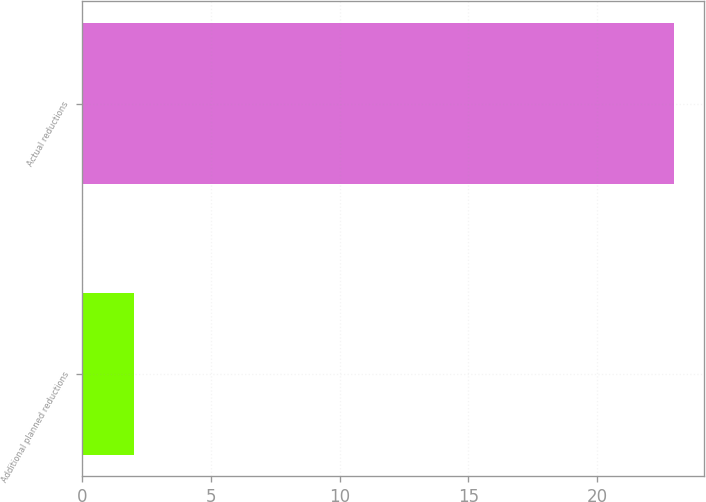Convert chart. <chart><loc_0><loc_0><loc_500><loc_500><bar_chart><fcel>Additional planned reductions<fcel>Actual reductions<nl><fcel>2<fcel>23<nl></chart> 